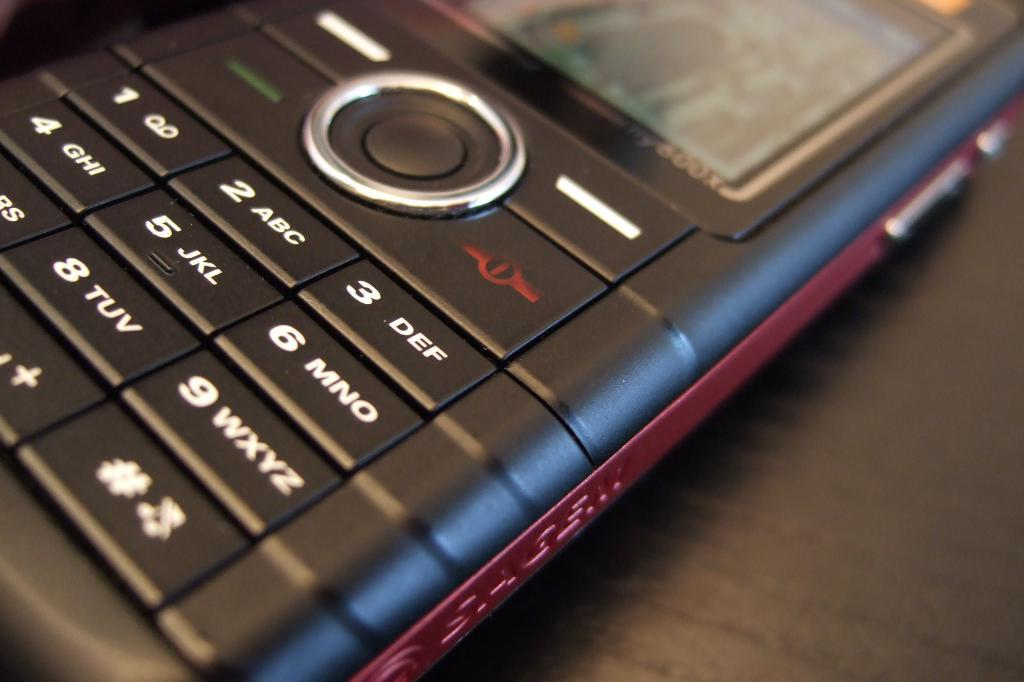<image>
Describe the image concisely. A closeup of an older model cellphone shows number buttons like 3. 